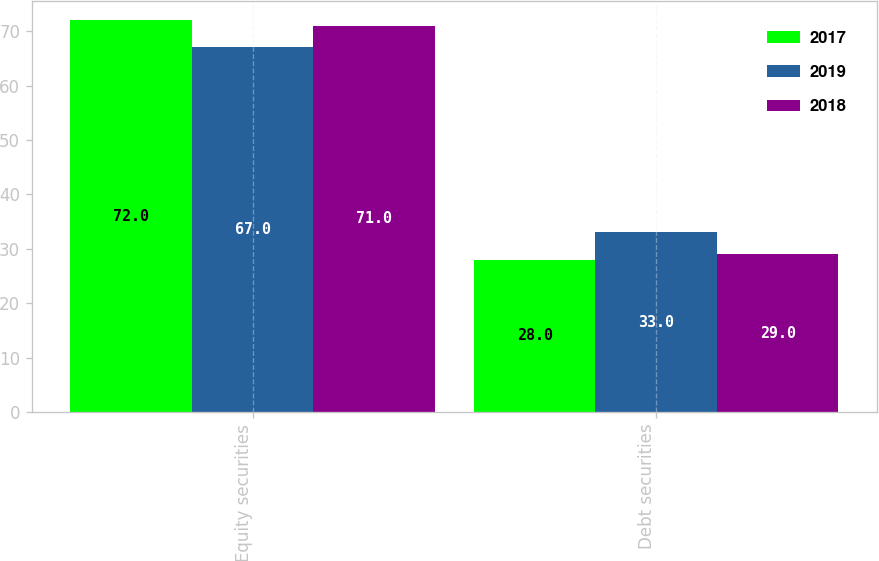<chart> <loc_0><loc_0><loc_500><loc_500><stacked_bar_chart><ecel><fcel>Equity securities<fcel>Debt securities<nl><fcel>2017<fcel>72<fcel>28<nl><fcel>2019<fcel>67<fcel>33<nl><fcel>2018<fcel>71<fcel>29<nl></chart> 